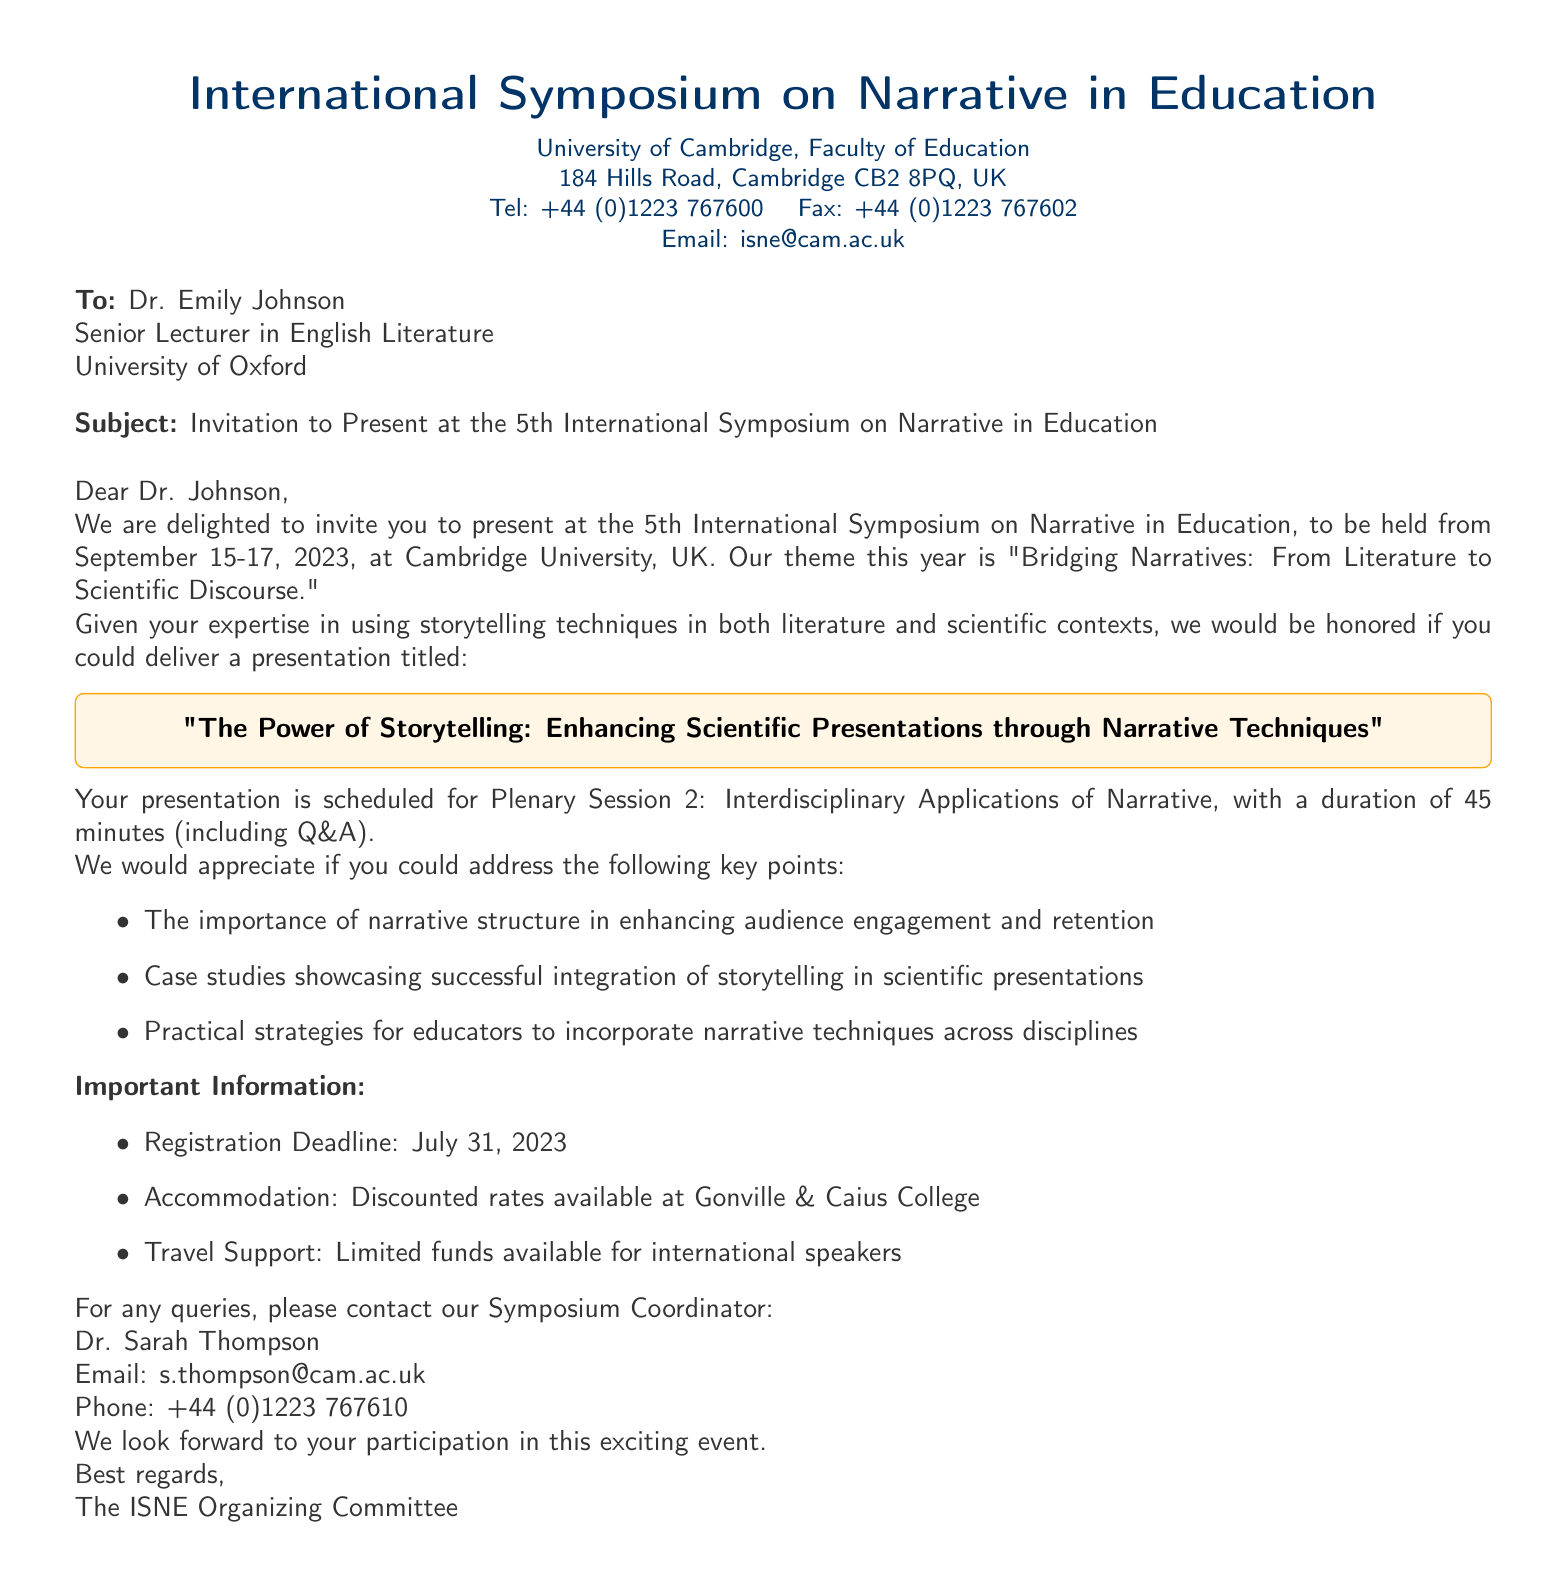What is the title of the symposium? The title of the symposium is indicated in the header of the document.
Answer: International Symposium on Narrative in Education Who is the invitation addressed to? The document specifies the recipient of the invitation in the "To" section.
Answer: Dr. Emily Johnson What is the theme of this year's symposium? The theme is mentioned in the invitation body.
Answer: Bridging Narratives: From Literature to Scientific Discourse What is the scheduled date of the event? The event dates are clearly stated in the introductory paragraph.
Answer: September 15-17, 2023 What is the duration of the presentation? The duration is outlined in the details about the planned presentation in the body text.
Answer: 45 minutes By when should the registration be completed? The registration deadline is specified in the "Important Information" section.
Answer: July 31, 2023 What is the contact email for queries? The email for inquiries is listed in the contact information of the document.
Answer: s.thompson@cam.ac.uk What is the presentation title Dr. Johnson is expected to deliver? The title of the presentation is highlighted in a box within the document.
Answer: The Power of Storytelling: Enhancing Scientific Presentations through Narrative Techniques Is there travel support available for presenters? The availability of travel support is mentioned in the "Important Information" section.
Answer: Yes, limited funds available 